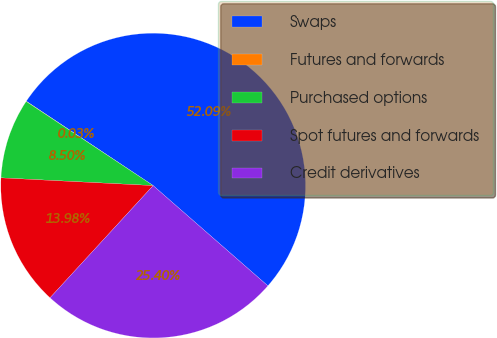Convert chart to OTSL. <chart><loc_0><loc_0><loc_500><loc_500><pie_chart><fcel>Swaps<fcel>Futures and forwards<fcel>Purchased options<fcel>Spot futures and forwards<fcel>Credit derivatives<nl><fcel>52.09%<fcel>0.03%<fcel>8.5%<fcel>13.98%<fcel>25.4%<nl></chart> 